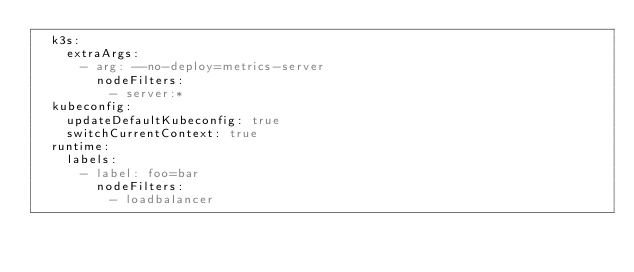<code> <loc_0><loc_0><loc_500><loc_500><_YAML_>  k3s:
    extraArgs:
      - arg: --no-deploy=metrics-server
        nodeFilters:
          - server:*
  kubeconfig:
    updateDefaultKubeconfig: true
    switchCurrentContext: true
  runtime:
    labels:
      - label: foo=bar
        nodeFilters:
          - loadbalancer
</code> 